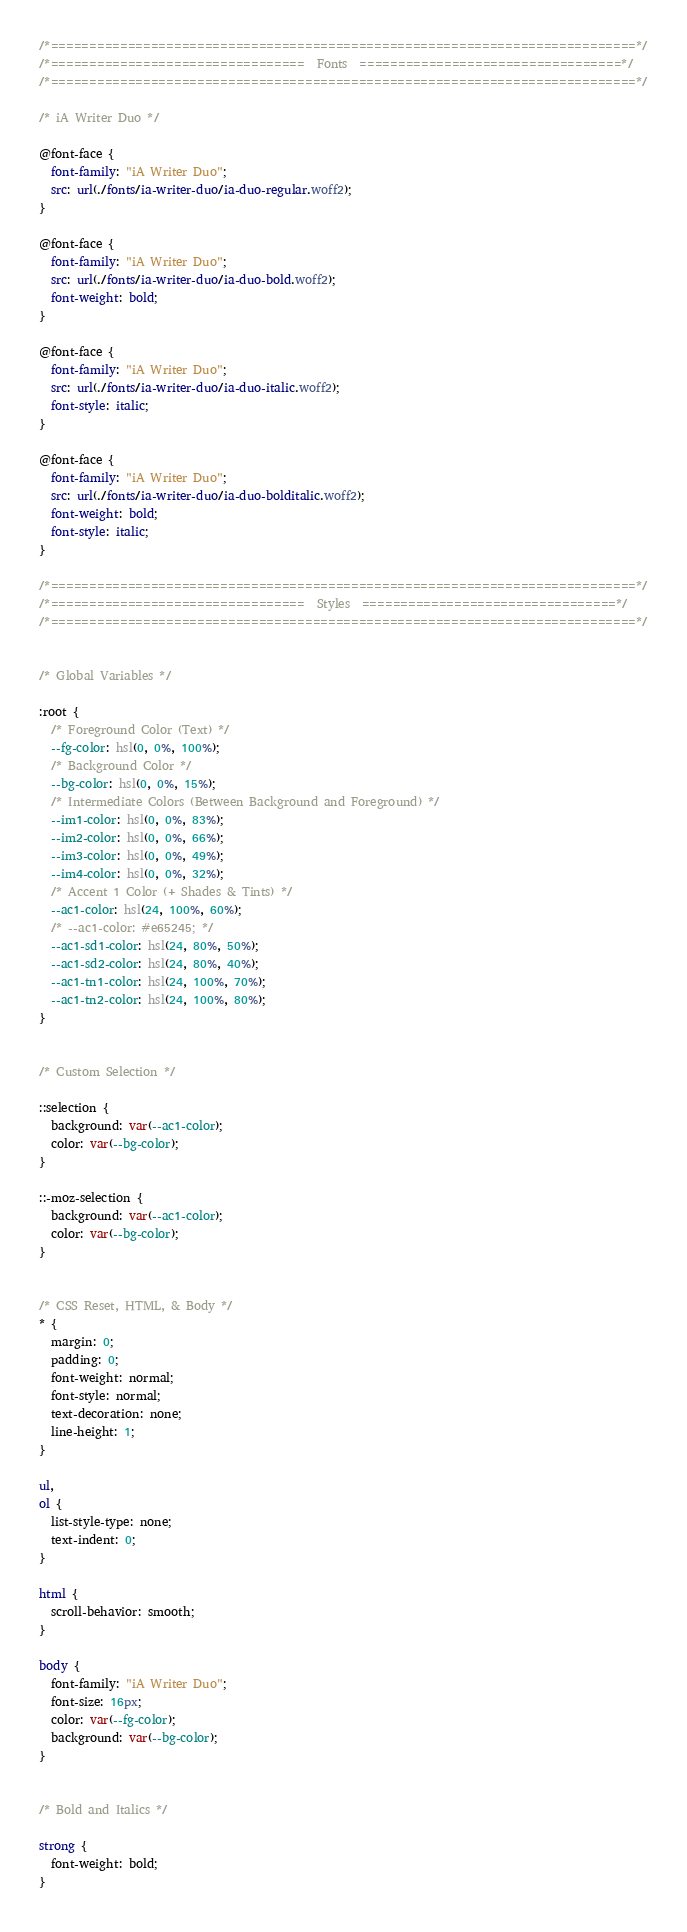<code> <loc_0><loc_0><loc_500><loc_500><_CSS_>
/*============================================================================*/
/*=================================  Fonts  ==================================*/
/*============================================================================*/

/* iA Writer Duo */

@font-face {
  font-family: "iA Writer Duo";
  src: url(./fonts/ia-writer-duo/ia-duo-regular.woff2);
}

@font-face {
  font-family: "iA Writer Duo";
  src: url(./fonts/ia-writer-duo/ia-duo-bold.woff2);
  font-weight: bold;
}

@font-face {
  font-family: "iA Writer Duo";
  src: url(./fonts/ia-writer-duo/ia-duo-italic.woff2);
  font-style: italic;
}

@font-face {
  font-family: "iA Writer Duo";
  src: url(./fonts/ia-writer-duo/ia-duo-bolditalic.woff2);
  font-weight: bold;
  font-style: italic;
}

/*============================================================================*/
/*=================================  Styles  =================================*/
/*============================================================================*/


/* Global Variables */

:root {
  /* Foreground Color (Text) */
  --fg-color: hsl(0, 0%, 100%);
  /* Background Color */
  --bg-color: hsl(0, 0%, 15%);
  /* Intermediate Colors (Between Background and Foreground) */
  --im1-color: hsl(0, 0%, 83%);
  --im2-color: hsl(0, 0%, 66%);
  --im3-color: hsl(0, 0%, 49%);
  --im4-color: hsl(0, 0%, 32%);
  /* Accent 1 Color (+ Shades & Tints) */
  --ac1-color: hsl(24, 100%, 60%);
  /* --ac1-color: #e65245; */
  --ac1-sd1-color: hsl(24, 80%, 50%);
  --ac1-sd2-color: hsl(24, 80%, 40%);
  --ac1-tn1-color: hsl(24, 100%, 70%);
  --ac1-tn2-color: hsl(24, 100%, 80%);
}


/* Custom Selection */

::selection {
  background: var(--ac1-color);
  color: var(--bg-color);
}

::-moz-selection {
  background: var(--ac1-color);
  color: var(--bg-color);
}


/* CSS Reset, HTML, & Body */
* {
  margin: 0;
  padding: 0;
  font-weight: normal;
  font-style: normal;
  text-decoration: none;
  line-height: 1;
}

ul,
ol {
  list-style-type: none;
  text-indent: 0;
}

html {
  scroll-behavior: smooth;
}

body {
  font-family: "iA Writer Duo";
  font-size: 16px;
  color: var(--fg-color);
  background: var(--bg-color);
}


/* Bold and Italics */

strong {
  font-weight: bold;
}
</code> 